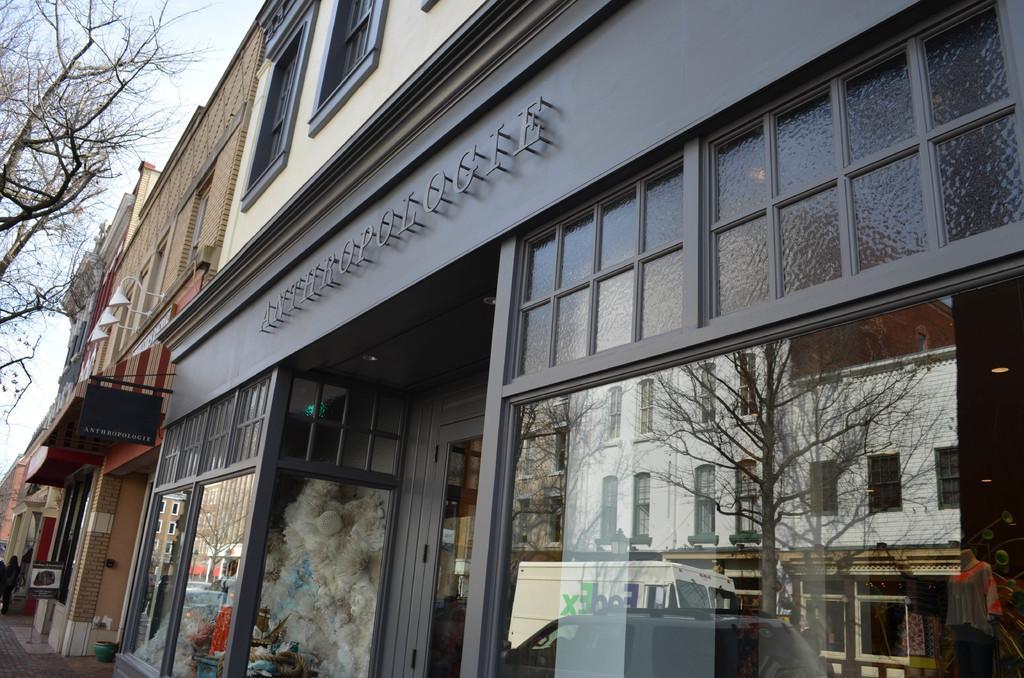Could you give a brief overview of what you see in this image? In the picture we can see a building with a windows and shops and glass walls and besides it also we can see some buildings with a pillar and some part of tree and a sky. 